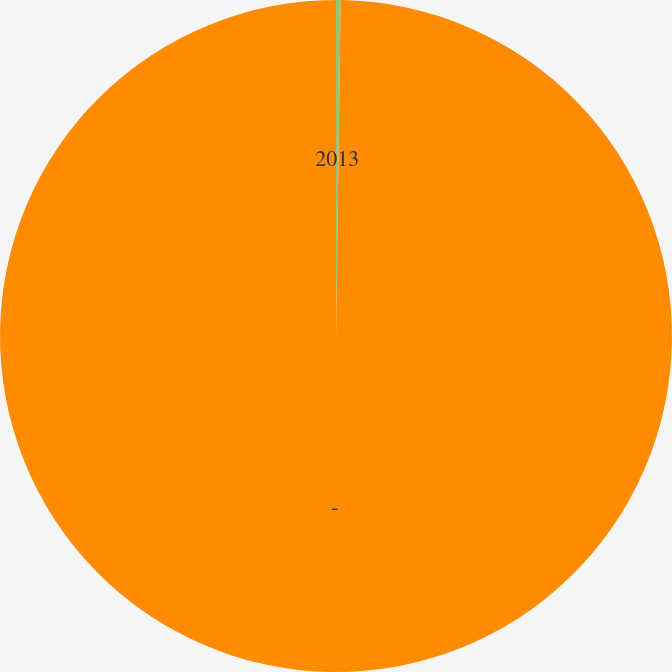Convert chart to OTSL. <chart><loc_0><loc_0><loc_500><loc_500><pie_chart><fcel>2013<fcel>-<nl><fcel>0.22%<fcel>99.78%<nl></chart> 